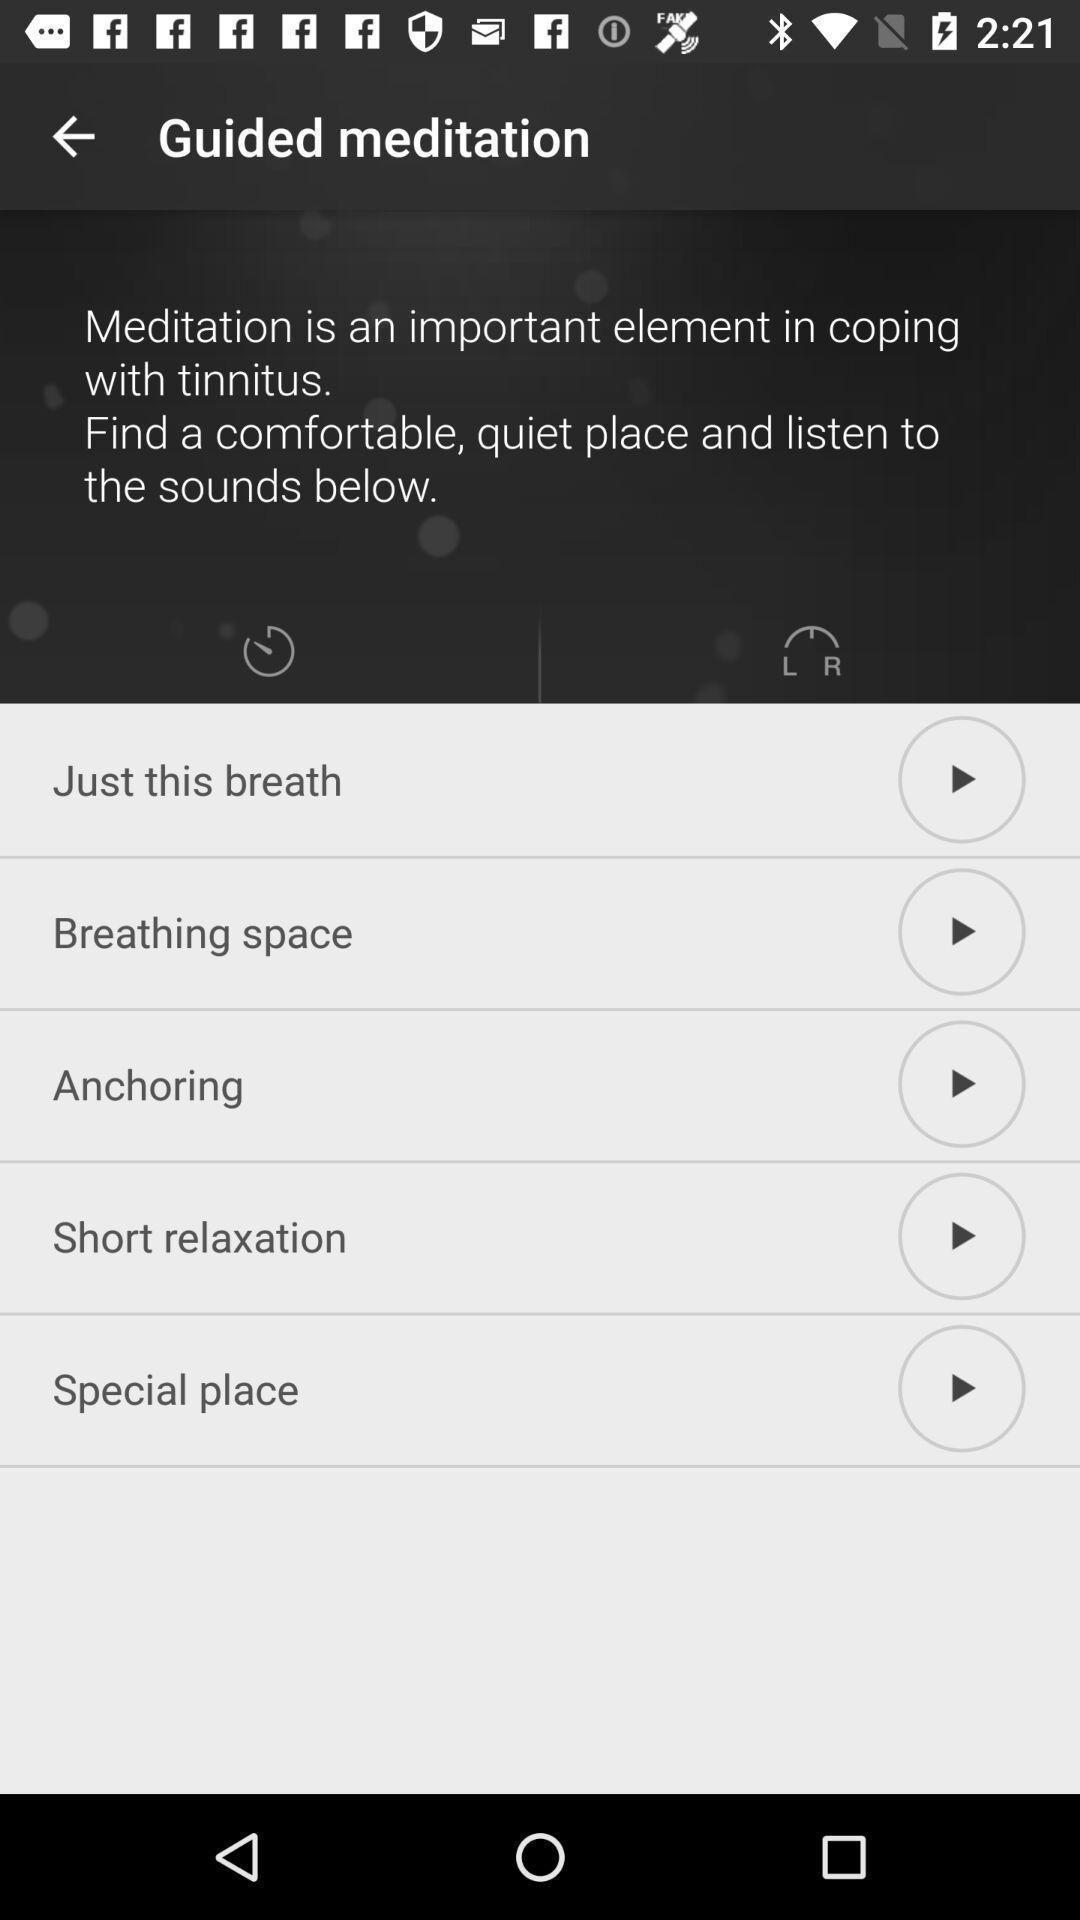Explain the elements present in this screenshot. Pop up displaying the multiple music options. 